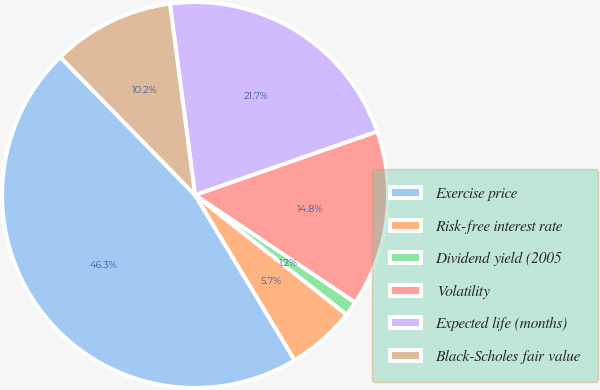Convert chart. <chart><loc_0><loc_0><loc_500><loc_500><pie_chart><fcel>Exercise price<fcel>Risk-free interest rate<fcel>Dividend yield (2005<fcel>Volatility<fcel>Expected life (months)<fcel>Black-Scholes fair value<nl><fcel>46.31%<fcel>5.73%<fcel>1.23%<fcel>14.75%<fcel>21.73%<fcel>10.24%<nl></chart> 